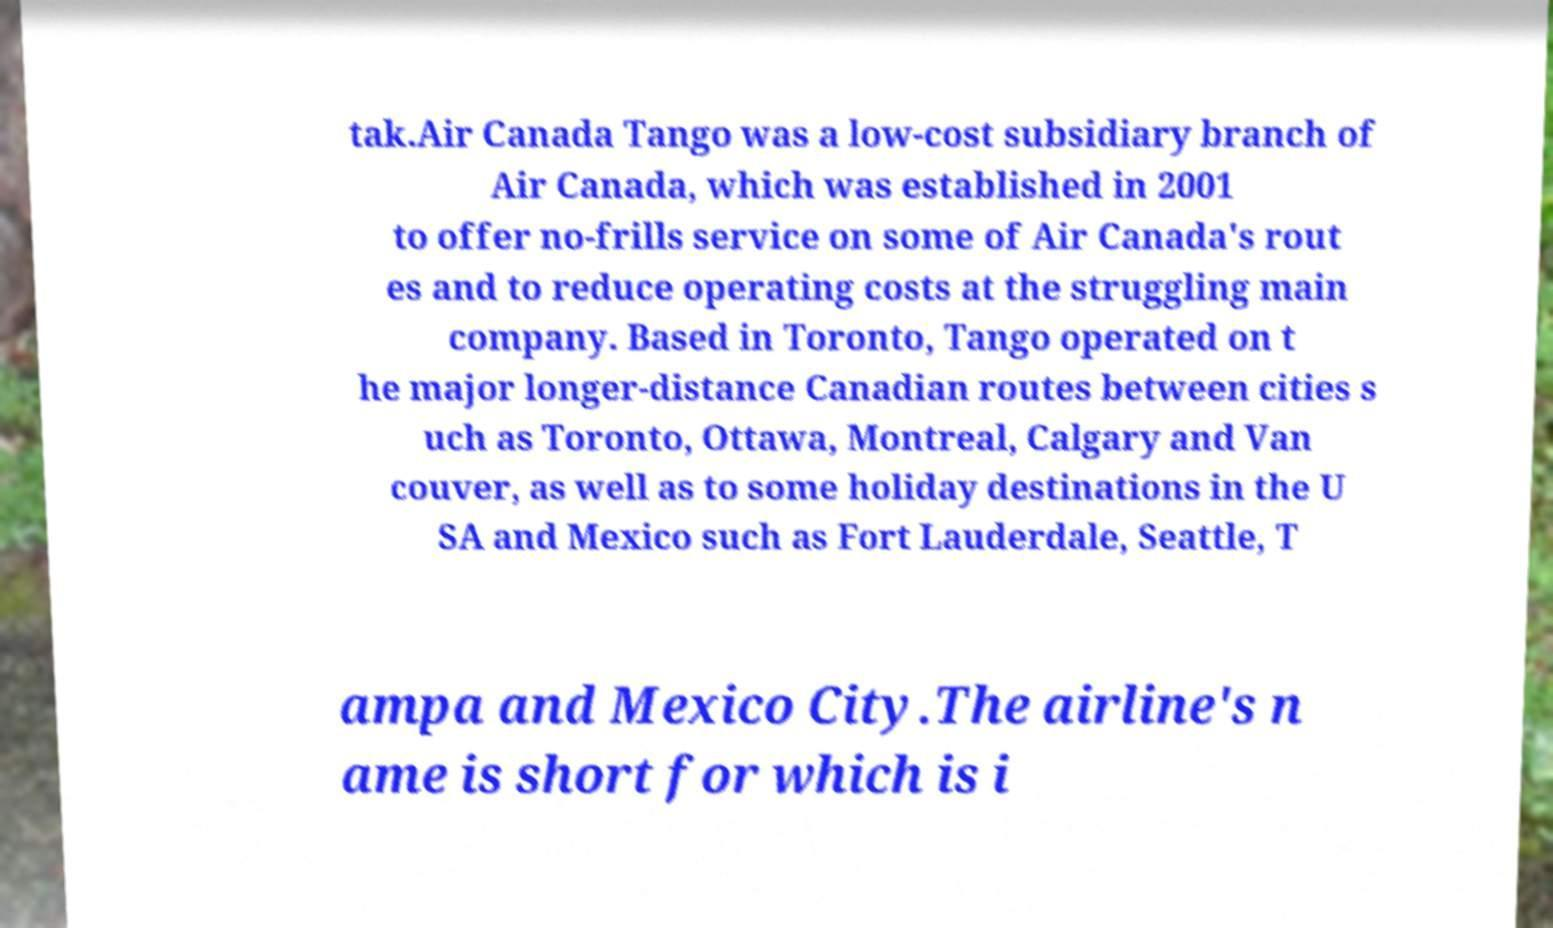Could you extract and type out the text from this image? tak.Air Canada Tango was a low-cost subsidiary branch of Air Canada, which was established in 2001 to offer no-frills service on some of Air Canada's rout es and to reduce operating costs at the struggling main company. Based in Toronto, Tango operated on t he major longer-distance Canadian routes between cities s uch as Toronto, Ottawa, Montreal, Calgary and Van couver, as well as to some holiday destinations in the U SA and Mexico such as Fort Lauderdale, Seattle, T ampa and Mexico City.The airline's n ame is short for which is i 